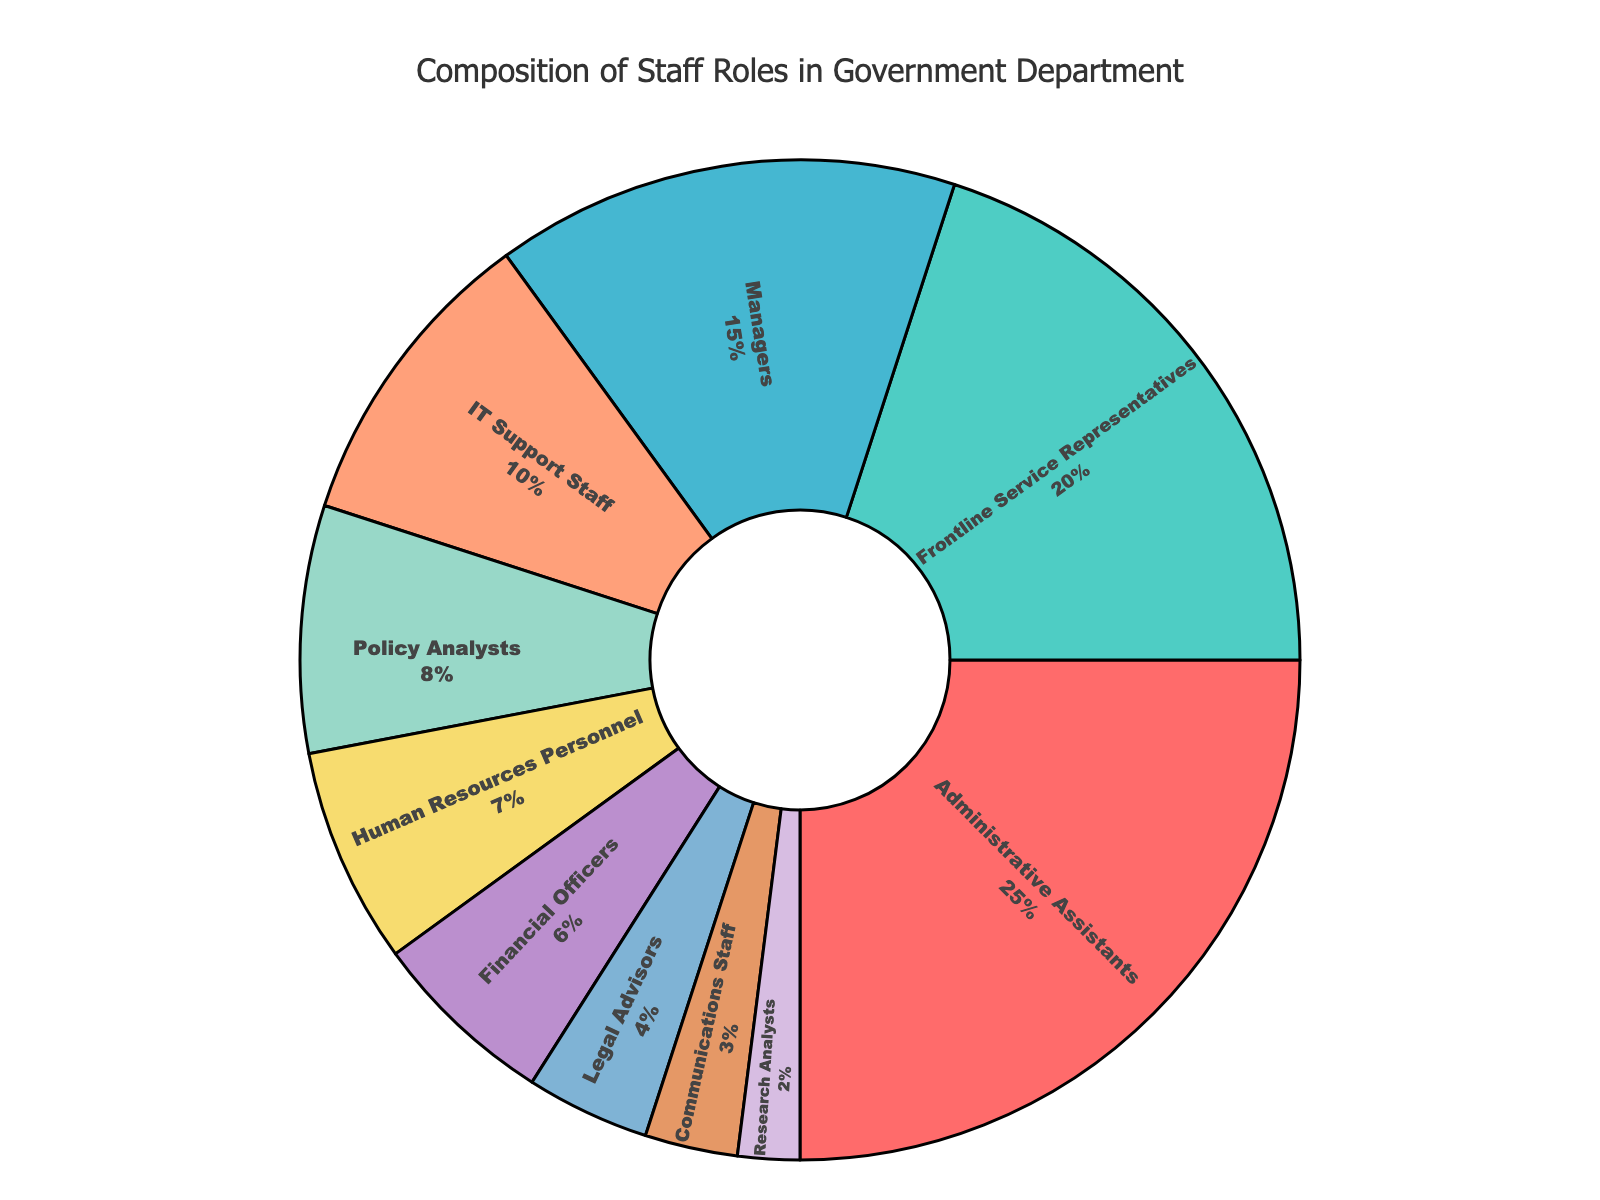What's the total percentage of roles for Administrative Assistants and Frontline Service Representatives combined? To find the combined percentage of Administrative Assistants and Frontline Service Representatives, add the percentages of these two roles: 25% (Administrative Assistants) + 20% (Frontline Service Representatives).
Answer: 45% Which role has a higher percentage, Managers or IT Support Staff? Compare the percentage values of Managers (15%) and IT Support Staff (10%). Since 15% is greater than 10%, Managers have a higher percentage.
Answer: Managers What is the difference in percentage between Policy Analysts and Human Resources Personnel? Subtract the percentage of Human Resources Personnel (7%) from the percentage of Policy Analysts (8%): 8% - 7%.
Answer: 1% Which role has the lowest percentage and what is that percentage? Look for the role with the smallest percentage value in the figure. The Research Analysts have the lowest percentage at 2%.
Answer: Research Analysts, 2% What percentage of the staff roles is composed of IT Support Staff, Financial Officers, and Legal Advisors combined? Sum the percentages for IT Support Staff (10%), Financial Officers (6%), and Legal Advisors (4%): 10% + 6% + 4%.
Answer: 20% How many roles have a percentage greater than 10%? Identify and count the roles with percentages greater than 10%. There are three such roles: Administrative Assistants (25%), Frontline Service Representatives (20%), and Managers (15%).
Answer: 3 Is the percentage of Communications Staff less than or equal to that of Research Analysts? Compare the percentage values for Communications Staff (3%) and Research Analysts (2%). Since 3% is greater than 2%, the percentage for Communications Staff is not less than or equal to that of Research Analysts.
Answer: No What color is used to represent Administrative Assistants in the figure? Identify the color segment in the figure that corresponds to Administrative Assistants. It is represented by the red color segment.
Answer: Red 